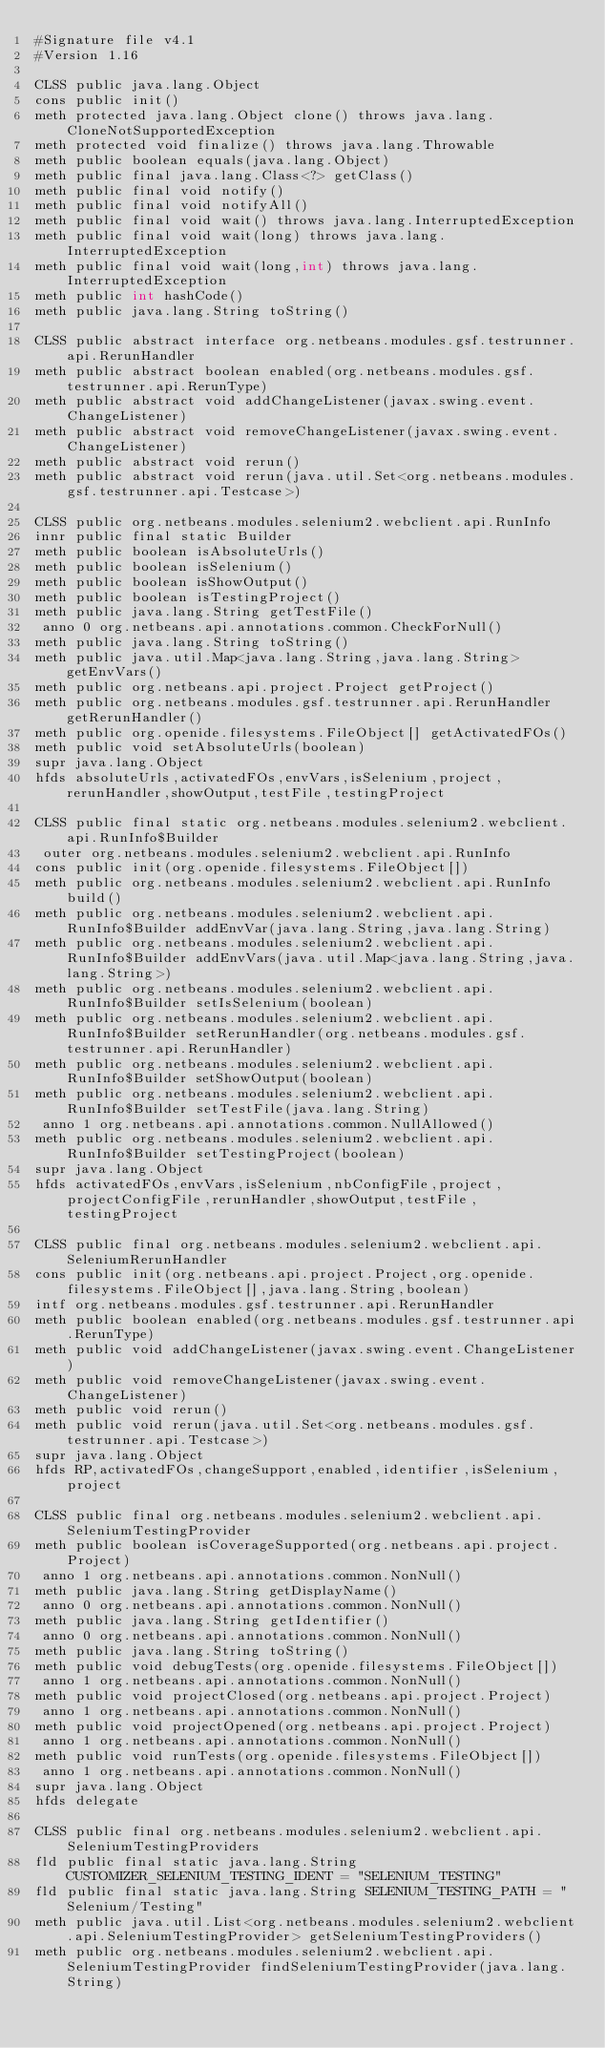<code> <loc_0><loc_0><loc_500><loc_500><_SML_>#Signature file v4.1
#Version 1.16

CLSS public java.lang.Object
cons public init()
meth protected java.lang.Object clone() throws java.lang.CloneNotSupportedException
meth protected void finalize() throws java.lang.Throwable
meth public boolean equals(java.lang.Object)
meth public final java.lang.Class<?> getClass()
meth public final void notify()
meth public final void notifyAll()
meth public final void wait() throws java.lang.InterruptedException
meth public final void wait(long) throws java.lang.InterruptedException
meth public final void wait(long,int) throws java.lang.InterruptedException
meth public int hashCode()
meth public java.lang.String toString()

CLSS public abstract interface org.netbeans.modules.gsf.testrunner.api.RerunHandler
meth public abstract boolean enabled(org.netbeans.modules.gsf.testrunner.api.RerunType)
meth public abstract void addChangeListener(javax.swing.event.ChangeListener)
meth public abstract void removeChangeListener(javax.swing.event.ChangeListener)
meth public abstract void rerun()
meth public abstract void rerun(java.util.Set<org.netbeans.modules.gsf.testrunner.api.Testcase>)

CLSS public org.netbeans.modules.selenium2.webclient.api.RunInfo
innr public final static Builder
meth public boolean isAbsoluteUrls()
meth public boolean isSelenium()
meth public boolean isShowOutput()
meth public boolean isTestingProject()
meth public java.lang.String getTestFile()
 anno 0 org.netbeans.api.annotations.common.CheckForNull()
meth public java.lang.String toString()
meth public java.util.Map<java.lang.String,java.lang.String> getEnvVars()
meth public org.netbeans.api.project.Project getProject()
meth public org.netbeans.modules.gsf.testrunner.api.RerunHandler getRerunHandler()
meth public org.openide.filesystems.FileObject[] getActivatedFOs()
meth public void setAbsoluteUrls(boolean)
supr java.lang.Object
hfds absoluteUrls,activatedFOs,envVars,isSelenium,project,rerunHandler,showOutput,testFile,testingProject

CLSS public final static org.netbeans.modules.selenium2.webclient.api.RunInfo$Builder
 outer org.netbeans.modules.selenium2.webclient.api.RunInfo
cons public init(org.openide.filesystems.FileObject[])
meth public org.netbeans.modules.selenium2.webclient.api.RunInfo build()
meth public org.netbeans.modules.selenium2.webclient.api.RunInfo$Builder addEnvVar(java.lang.String,java.lang.String)
meth public org.netbeans.modules.selenium2.webclient.api.RunInfo$Builder addEnvVars(java.util.Map<java.lang.String,java.lang.String>)
meth public org.netbeans.modules.selenium2.webclient.api.RunInfo$Builder setIsSelenium(boolean)
meth public org.netbeans.modules.selenium2.webclient.api.RunInfo$Builder setRerunHandler(org.netbeans.modules.gsf.testrunner.api.RerunHandler)
meth public org.netbeans.modules.selenium2.webclient.api.RunInfo$Builder setShowOutput(boolean)
meth public org.netbeans.modules.selenium2.webclient.api.RunInfo$Builder setTestFile(java.lang.String)
 anno 1 org.netbeans.api.annotations.common.NullAllowed()
meth public org.netbeans.modules.selenium2.webclient.api.RunInfo$Builder setTestingProject(boolean)
supr java.lang.Object
hfds activatedFOs,envVars,isSelenium,nbConfigFile,project,projectConfigFile,rerunHandler,showOutput,testFile,testingProject

CLSS public final org.netbeans.modules.selenium2.webclient.api.SeleniumRerunHandler
cons public init(org.netbeans.api.project.Project,org.openide.filesystems.FileObject[],java.lang.String,boolean)
intf org.netbeans.modules.gsf.testrunner.api.RerunHandler
meth public boolean enabled(org.netbeans.modules.gsf.testrunner.api.RerunType)
meth public void addChangeListener(javax.swing.event.ChangeListener)
meth public void removeChangeListener(javax.swing.event.ChangeListener)
meth public void rerun()
meth public void rerun(java.util.Set<org.netbeans.modules.gsf.testrunner.api.Testcase>)
supr java.lang.Object
hfds RP,activatedFOs,changeSupport,enabled,identifier,isSelenium,project

CLSS public final org.netbeans.modules.selenium2.webclient.api.SeleniumTestingProvider
meth public boolean isCoverageSupported(org.netbeans.api.project.Project)
 anno 1 org.netbeans.api.annotations.common.NonNull()
meth public java.lang.String getDisplayName()
 anno 0 org.netbeans.api.annotations.common.NonNull()
meth public java.lang.String getIdentifier()
 anno 0 org.netbeans.api.annotations.common.NonNull()
meth public java.lang.String toString()
meth public void debugTests(org.openide.filesystems.FileObject[])
 anno 1 org.netbeans.api.annotations.common.NonNull()
meth public void projectClosed(org.netbeans.api.project.Project)
 anno 1 org.netbeans.api.annotations.common.NonNull()
meth public void projectOpened(org.netbeans.api.project.Project)
 anno 1 org.netbeans.api.annotations.common.NonNull()
meth public void runTests(org.openide.filesystems.FileObject[])
 anno 1 org.netbeans.api.annotations.common.NonNull()
supr java.lang.Object
hfds delegate

CLSS public final org.netbeans.modules.selenium2.webclient.api.SeleniumTestingProviders
fld public final static java.lang.String CUSTOMIZER_SELENIUM_TESTING_IDENT = "SELENIUM_TESTING"
fld public final static java.lang.String SELENIUM_TESTING_PATH = "Selenium/Testing"
meth public java.util.List<org.netbeans.modules.selenium2.webclient.api.SeleniumTestingProvider> getSeleniumTestingProviders()
meth public org.netbeans.modules.selenium2.webclient.api.SeleniumTestingProvider findSeleniumTestingProvider(java.lang.String)</code> 